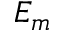Convert formula to latex. <formula><loc_0><loc_0><loc_500><loc_500>E _ { m }</formula> 